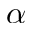<formula> <loc_0><loc_0><loc_500><loc_500>\alpha</formula> 